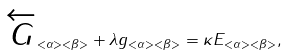<formula> <loc_0><loc_0><loc_500><loc_500>\overleftarrow { G } _ { < \alpha > < \beta > } + \lambda g _ { < \alpha > < \beta > } = \kappa E _ { < \alpha > < \beta > } ,</formula> 